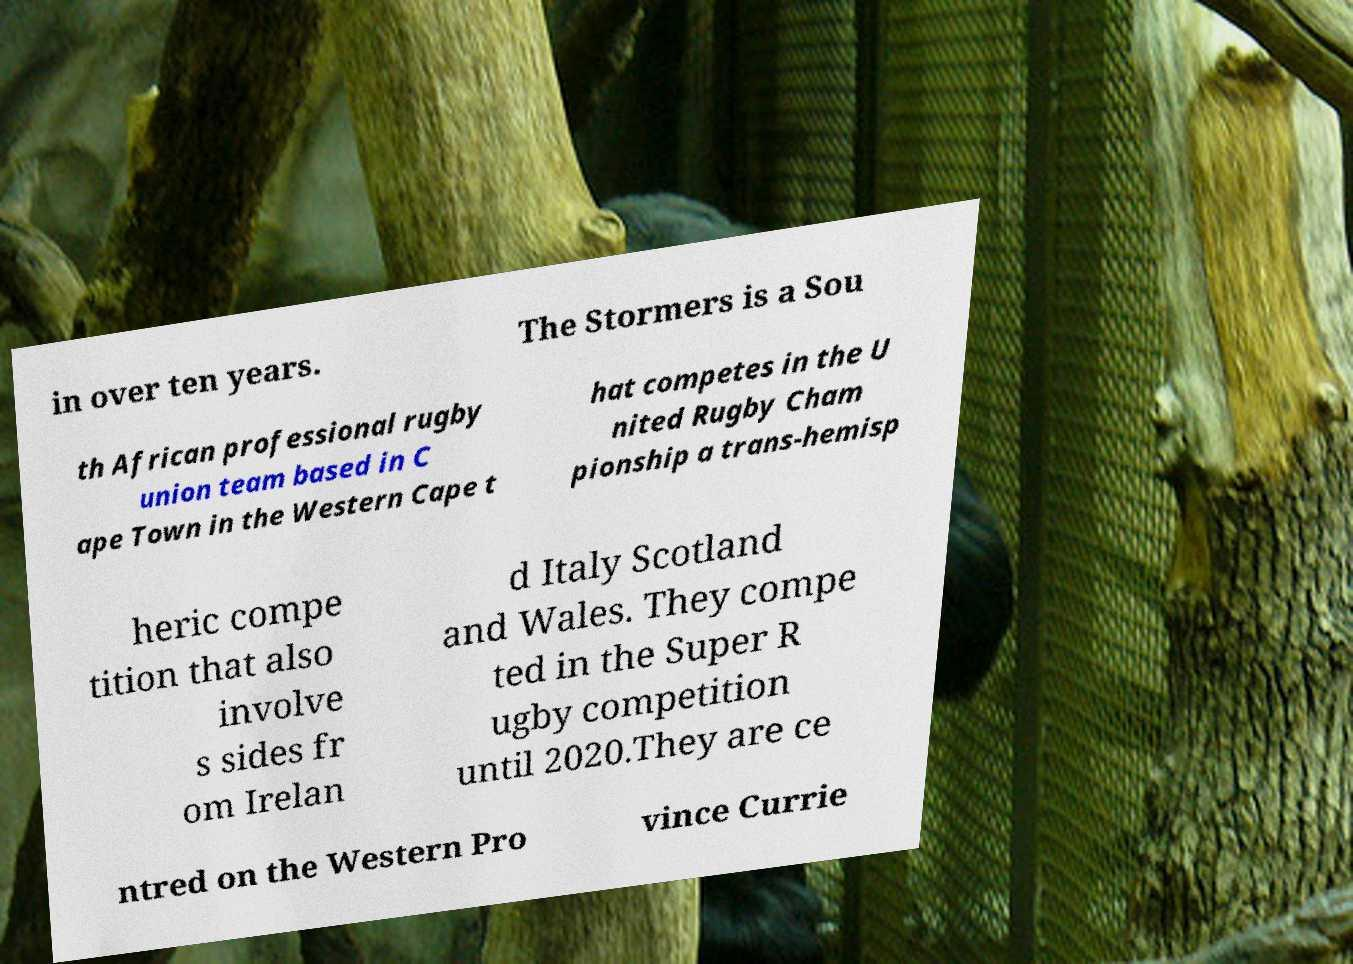Could you assist in decoding the text presented in this image and type it out clearly? in over ten years. The Stormers is a Sou th African professional rugby union team based in C ape Town in the Western Cape t hat competes in the U nited Rugby Cham pionship a trans-hemisp heric compe tition that also involve s sides fr om Irelan d Italy Scotland and Wales. They compe ted in the Super R ugby competition until 2020.They are ce ntred on the Western Pro vince Currie 